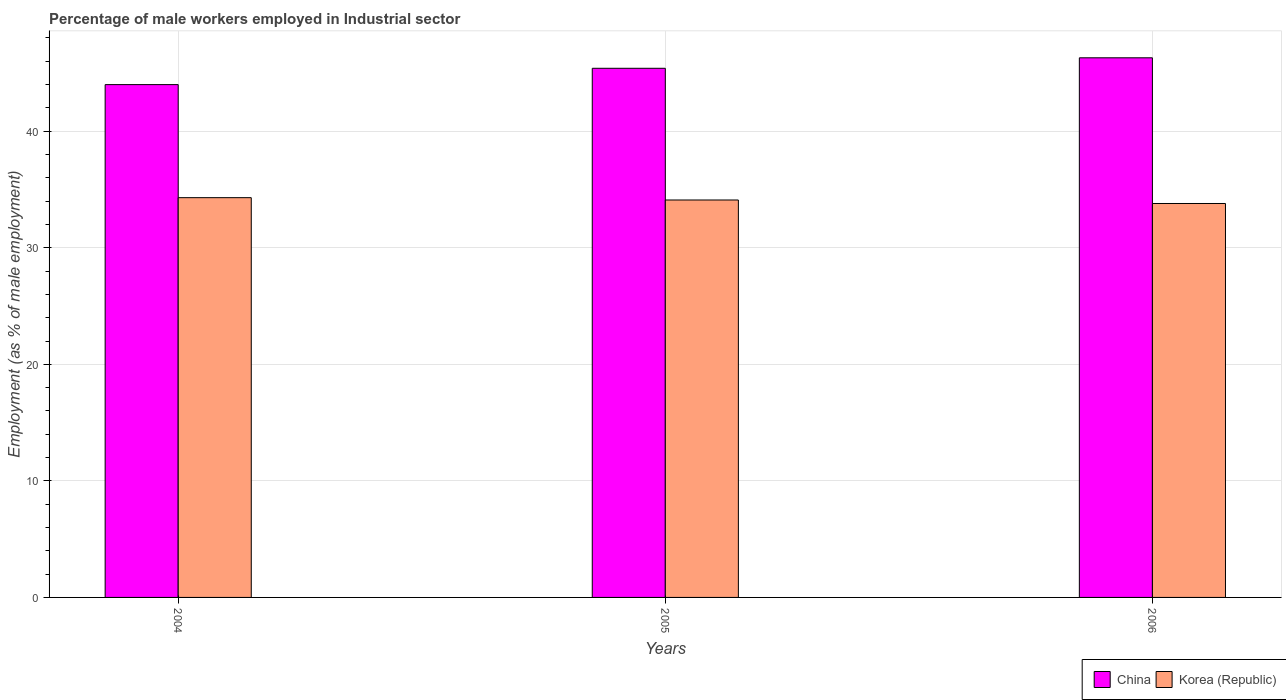How many groups of bars are there?
Your response must be concise. 3. Are the number of bars per tick equal to the number of legend labels?
Your answer should be very brief. Yes. Are the number of bars on each tick of the X-axis equal?
Your answer should be compact. Yes. In how many cases, is the number of bars for a given year not equal to the number of legend labels?
Provide a succinct answer. 0. What is the percentage of male workers employed in Industrial sector in China in 2004?
Your answer should be very brief. 44. Across all years, what is the maximum percentage of male workers employed in Industrial sector in China?
Provide a succinct answer. 46.3. Across all years, what is the minimum percentage of male workers employed in Industrial sector in China?
Your answer should be compact. 44. In which year was the percentage of male workers employed in Industrial sector in Korea (Republic) maximum?
Give a very brief answer. 2004. What is the total percentage of male workers employed in Industrial sector in China in the graph?
Offer a terse response. 135.7. What is the difference between the percentage of male workers employed in Industrial sector in Korea (Republic) in 2005 and that in 2006?
Make the answer very short. 0.3. What is the difference between the percentage of male workers employed in Industrial sector in Korea (Republic) in 2005 and the percentage of male workers employed in Industrial sector in China in 2004?
Your answer should be compact. -9.9. What is the average percentage of male workers employed in Industrial sector in Korea (Republic) per year?
Give a very brief answer. 34.07. In the year 2005, what is the difference between the percentage of male workers employed in Industrial sector in Korea (Republic) and percentage of male workers employed in Industrial sector in China?
Offer a terse response. -11.3. In how many years, is the percentage of male workers employed in Industrial sector in Korea (Republic) greater than 12 %?
Offer a very short reply. 3. What is the ratio of the percentage of male workers employed in Industrial sector in Korea (Republic) in 2004 to that in 2006?
Provide a succinct answer. 1.01. Is the difference between the percentage of male workers employed in Industrial sector in Korea (Republic) in 2004 and 2006 greater than the difference between the percentage of male workers employed in Industrial sector in China in 2004 and 2006?
Your answer should be very brief. Yes. What is the difference between the highest and the second highest percentage of male workers employed in Industrial sector in Korea (Republic)?
Your answer should be compact. 0.2. What is the difference between the highest and the lowest percentage of male workers employed in Industrial sector in Korea (Republic)?
Give a very brief answer. 0.5. Is the sum of the percentage of male workers employed in Industrial sector in China in 2004 and 2005 greater than the maximum percentage of male workers employed in Industrial sector in Korea (Republic) across all years?
Give a very brief answer. Yes. What does the 1st bar from the right in 2005 represents?
Offer a terse response. Korea (Republic). How many bars are there?
Your response must be concise. 6. What is the difference between two consecutive major ticks on the Y-axis?
Provide a short and direct response. 10. Does the graph contain grids?
Provide a succinct answer. Yes. Where does the legend appear in the graph?
Provide a succinct answer. Bottom right. How many legend labels are there?
Offer a very short reply. 2. How are the legend labels stacked?
Your response must be concise. Horizontal. What is the title of the graph?
Offer a very short reply. Percentage of male workers employed in Industrial sector. Does "Brunei Darussalam" appear as one of the legend labels in the graph?
Ensure brevity in your answer.  No. What is the label or title of the Y-axis?
Your response must be concise. Employment (as % of male employment). What is the Employment (as % of male employment) of China in 2004?
Ensure brevity in your answer.  44. What is the Employment (as % of male employment) in Korea (Republic) in 2004?
Ensure brevity in your answer.  34.3. What is the Employment (as % of male employment) of China in 2005?
Provide a short and direct response. 45.4. What is the Employment (as % of male employment) of Korea (Republic) in 2005?
Your answer should be compact. 34.1. What is the Employment (as % of male employment) in China in 2006?
Offer a very short reply. 46.3. What is the Employment (as % of male employment) in Korea (Republic) in 2006?
Offer a terse response. 33.8. Across all years, what is the maximum Employment (as % of male employment) of China?
Your answer should be very brief. 46.3. Across all years, what is the maximum Employment (as % of male employment) in Korea (Republic)?
Ensure brevity in your answer.  34.3. Across all years, what is the minimum Employment (as % of male employment) in Korea (Republic)?
Offer a very short reply. 33.8. What is the total Employment (as % of male employment) in China in the graph?
Ensure brevity in your answer.  135.7. What is the total Employment (as % of male employment) of Korea (Republic) in the graph?
Your answer should be very brief. 102.2. What is the difference between the Employment (as % of male employment) of China in 2004 and that in 2005?
Keep it short and to the point. -1.4. What is the difference between the Employment (as % of male employment) of China in 2004 and that in 2006?
Provide a succinct answer. -2.3. What is the difference between the Employment (as % of male employment) of Korea (Republic) in 2004 and that in 2006?
Give a very brief answer. 0.5. What is the difference between the Employment (as % of male employment) in China in 2005 and that in 2006?
Provide a succinct answer. -0.9. What is the difference between the Employment (as % of male employment) of Korea (Republic) in 2005 and that in 2006?
Keep it short and to the point. 0.3. What is the difference between the Employment (as % of male employment) of China in 2004 and the Employment (as % of male employment) of Korea (Republic) in 2006?
Give a very brief answer. 10.2. What is the difference between the Employment (as % of male employment) in China in 2005 and the Employment (as % of male employment) in Korea (Republic) in 2006?
Provide a succinct answer. 11.6. What is the average Employment (as % of male employment) in China per year?
Make the answer very short. 45.23. What is the average Employment (as % of male employment) of Korea (Republic) per year?
Offer a very short reply. 34.07. What is the ratio of the Employment (as % of male employment) in China in 2004 to that in 2005?
Your response must be concise. 0.97. What is the ratio of the Employment (as % of male employment) of Korea (Republic) in 2004 to that in 2005?
Give a very brief answer. 1.01. What is the ratio of the Employment (as % of male employment) in China in 2004 to that in 2006?
Make the answer very short. 0.95. What is the ratio of the Employment (as % of male employment) of Korea (Republic) in 2004 to that in 2006?
Your answer should be compact. 1.01. What is the ratio of the Employment (as % of male employment) in China in 2005 to that in 2006?
Provide a succinct answer. 0.98. What is the ratio of the Employment (as % of male employment) of Korea (Republic) in 2005 to that in 2006?
Offer a very short reply. 1.01. What is the difference between the highest and the second highest Employment (as % of male employment) in Korea (Republic)?
Your response must be concise. 0.2. What is the difference between the highest and the lowest Employment (as % of male employment) of China?
Your answer should be compact. 2.3. 